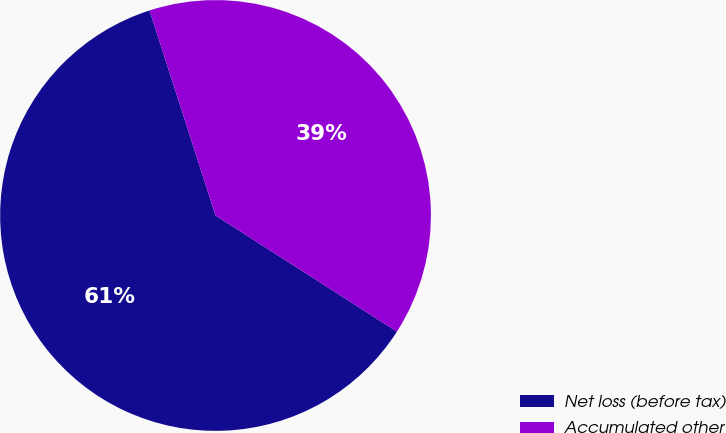Convert chart. <chart><loc_0><loc_0><loc_500><loc_500><pie_chart><fcel>Net loss (before tax)<fcel>Accumulated other<nl><fcel>60.98%<fcel>39.02%<nl></chart> 